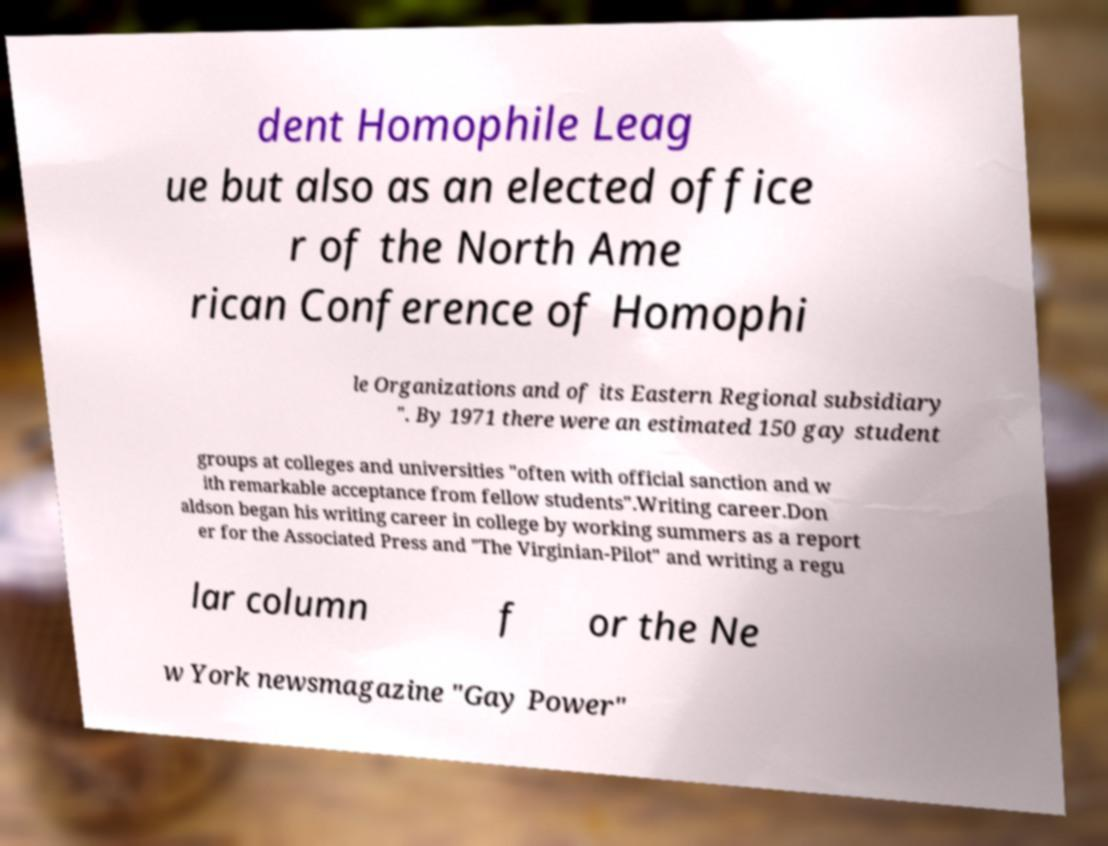Can you accurately transcribe the text from the provided image for me? dent Homophile Leag ue but also as an elected office r of the North Ame rican Conference of Homophi le Organizations and of its Eastern Regional subsidiary ". By 1971 there were an estimated 150 gay student groups at colleges and universities "often with official sanction and w ith remarkable acceptance from fellow students".Writing career.Don aldson began his writing career in college by working summers as a report er for the Associated Press and "The Virginian-Pilot" and writing a regu lar column f or the Ne w York newsmagazine "Gay Power" 